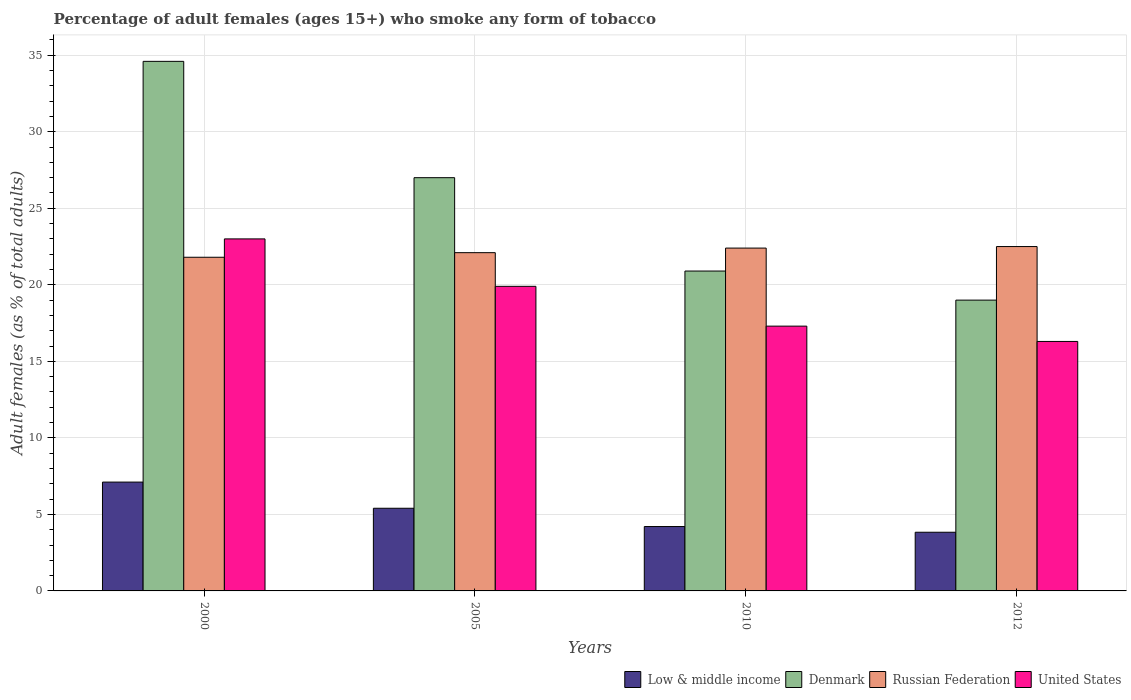How many different coloured bars are there?
Offer a very short reply. 4. How many groups of bars are there?
Keep it short and to the point. 4. Are the number of bars per tick equal to the number of legend labels?
Make the answer very short. Yes. In how many cases, is the number of bars for a given year not equal to the number of legend labels?
Make the answer very short. 0. What is the percentage of adult females who smoke in Denmark in 2010?
Make the answer very short. 20.9. In which year was the percentage of adult females who smoke in Low & middle income maximum?
Offer a terse response. 2000. What is the total percentage of adult females who smoke in United States in the graph?
Your answer should be very brief. 76.5. What is the difference between the percentage of adult females who smoke in United States in 2000 and that in 2005?
Provide a succinct answer. 3.1. What is the difference between the percentage of adult females who smoke in Denmark in 2010 and the percentage of adult females who smoke in United States in 2012?
Your answer should be compact. 4.6. What is the average percentage of adult females who smoke in United States per year?
Your answer should be compact. 19.12. In the year 2005, what is the difference between the percentage of adult females who smoke in Denmark and percentage of adult females who smoke in United States?
Give a very brief answer. 7.1. In how many years, is the percentage of adult females who smoke in Low & middle income greater than 7 %?
Provide a short and direct response. 1. What is the ratio of the percentage of adult females who smoke in Russian Federation in 2005 to that in 2010?
Your response must be concise. 0.99. Is the percentage of adult females who smoke in Denmark in 2000 less than that in 2010?
Offer a terse response. No. What is the difference between the highest and the second highest percentage of adult females who smoke in Denmark?
Ensure brevity in your answer.  7.6. What is the difference between the highest and the lowest percentage of adult females who smoke in Low & middle income?
Ensure brevity in your answer.  3.28. Is the sum of the percentage of adult females who smoke in Denmark in 2005 and 2012 greater than the maximum percentage of adult females who smoke in United States across all years?
Offer a terse response. Yes. What does the 1st bar from the left in 2000 represents?
Offer a terse response. Low & middle income. Are all the bars in the graph horizontal?
Your response must be concise. No. How many years are there in the graph?
Give a very brief answer. 4. What is the difference between two consecutive major ticks on the Y-axis?
Provide a short and direct response. 5. Does the graph contain grids?
Provide a short and direct response. Yes. Where does the legend appear in the graph?
Provide a succinct answer. Bottom right. How are the legend labels stacked?
Your answer should be very brief. Horizontal. What is the title of the graph?
Offer a very short reply. Percentage of adult females (ages 15+) who smoke any form of tobacco. What is the label or title of the Y-axis?
Your answer should be compact. Adult females (as % of total adults). What is the Adult females (as % of total adults) of Low & middle income in 2000?
Your answer should be compact. 7.11. What is the Adult females (as % of total adults) of Denmark in 2000?
Ensure brevity in your answer.  34.6. What is the Adult females (as % of total adults) of Russian Federation in 2000?
Give a very brief answer. 21.8. What is the Adult females (as % of total adults) in Low & middle income in 2005?
Offer a very short reply. 5.4. What is the Adult females (as % of total adults) in Russian Federation in 2005?
Offer a very short reply. 22.1. What is the Adult females (as % of total adults) of Low & middle income in 2010?
Your answer should be compact. 4.21. What is the Adult females (as % of total adults) of Denmark in 2010?
Make the answer very short. 20.9. What is the Adult females (as % of total adults) in Russian Federation in 2010?
Provide a succinct answer. 22.4. What is the Adult females (as % of total adults) in United States in 2010?
Offer a terse response. 17.3. What is the Adult females (as % of total adults) in Low & middle income in 2012?
Provide a short and direct response. 3.83. What is the Adult females (as % of total adults) of Russian Federation in 2012?
Offer a very short reply. 22.5. What is the Adult females (as % of total adults) of United States in 2012?
Your answer should be compact. 16.3. Across all years, what is the maximum Adult females (as % of total adults) of Low & middle income?
Your answer should be compact. 7.11. Across all years, what is the maximum Adult females (as % of total adults) of Denmark?
Provide a short and direct response. 34.6. Across all years, what is the maximum Adult females (as % of total adults) of Russian Federation?
Provide a short and direct response. 22.5. Across all years, what is the maximum Adult females (as % of total adults) of United States?
Provide a succinct answer. 23. Across all years, what is the minimum Adult females (as % of total adults) of Low & middle income?
Provide a short and direct response. 3.83. Across all years, what is the minimum Adult females (as % of total adults) in Russian Federation?
Ensure brevity in your answer.  21.8. Across all years, what is the minimum Adult females (as % of total adults) in United States?
Give a very brief answer. 16.3. What is the total Adult females (as % of total adults) of Low & middle income in the graph?
Keep it short and to the point. 20.55. What is the total Adult females (as % of total adults) in Denmark in the graph?
Provide a short and direct response. 101.5. What is the total Adult females (as % of total adults) in Russian Federation in the graph?
Ensure brevity in your answer.  88.8. What is the total Adult females (as % of total adults) in United States in the graph?
Offer a very short reply. 76.5. What is the difference between the Adult females (as % of total adults) in Low & middle income in 2000 and that in 2005?
Your response must be concise. 1.71. What is the difference between the Adult females (as % of total adults) in Denmark in 2000 and that in 2005?
Ensure brevity in your answer.  7.6. What is the difference between the Adult females (as % of total adults) of United States in 2000 and that in 2005?
Your answer should be compact. 3.1. What is the difference between the Adult females (as % of total adults) of Low & middle income in 2000 and that in 2010?
Your response must be concise. 2.9. What is the difference between the Adult females (as % of total adults) in United States in 2000 and that in 2010?
Ensure brevity in your answer.  5.7. What is the difference between the Adult females (as % of total adults) in Low & middle income in 2000 and that in 2012?
Ensure brevity in your answer.  3.28. What is the difference between the Adult females (as % of total adults) in Russian Federation in 2000 and that in 2012?
Make the answer very short. -0.7. What is the difference between the Adult females (as % of total adults) of United States in 2000 and that in 2012?
Your response must be concise. 6.7. What is the difference between the Adult females (as % of total adults) in Low & middle income in 2005 and that in 2010?
Provide a short and direct response. 1.19. What is the difference between the Adult females (as % of total adults) in Denmark in 2005 and that in 2010?
Your answer should be very brief. 6.1. What is the difference between the Adult females (as % of total adults) in Low & middle income in 2005 and that in 2012?
Make the answer very short. 1.57. What is the difference between the Adult females (as % of total adults) in Denmark in 2005 and that in 2012?
Your answer should be compact. 8. What is the difference between the Adult females (as % of total adults) of Russian Federation in 2005 and that in 2012?
Offer a terse response. -0.4. What is the difference between the Adult females (as % of total adults) in United States in 2005 and that in 2012?
Your answer should be very brief. 3.6. What is the difference between the Adult females (as % of total adults) in Low & middle income in 2010 and that in 2012?
Make the answer very short. 0.37. What is the difference between the Adult females (as % of total adults) of Low & middle income in 2000 and the Adult females (as % of total adults) of Denmark in 2005?
Offer a terse response. -19.89. What is the difference between the Adult females (as % of total adults) in Low & middle income in 2000 and the Adult females (as % of total adults) in Russian Federation in 2005?
Your answer should be very brief. -14.99. What is the difference between the Adult females (as % of total adults) in Low & middle income in 2000 and the Adult females (as % of total adults) in United States in 2005?
Offer a terse response. -12.79. What is the difference between the Adult females (as % of total adults) of Russian Federation in 2000 and the Adult females (as % of total adults) of United States in 2005?
Offer a terse response. 1.9. What is the difference between the Adult females (as % of total adults) in Low & middle income in 2000 and the Adult females (as % of total adults) in Denmark in 2010?
Ensure brevity in your answer.  -13.79. What is the difference between the Adult females (as % of total adults) in Low & middle income in 2000 and the Adult females (as % of total adults) in Russian Federation in 2010?
Your answer should be very brief. -15.29. What is the difference between the Adult females (as % of total adults) in Low & middle income in 2000 and the Adult females (as % of total adults) in United States in 2010?
Offer a very short reply. -10.19. What is the difference between the Adult females (as % of total adults) in Low & middle income in 2000 and the Adult females (as % of total adults) in Denmark in 2012?
Offer a terse response. -11.89. What is the difference between the Adult females (as % of total adults) of Low & middle income in 2000 and the Adult females (as % of total adults) of Russian Federation in 2012?
Give a very brief answer. -15.39. What is the difference between the Adult females (as % of total adults) in Low & middle income in 2000 and the Adult females (as % of total adults) in United States in 2012?
Provide a short and direct response. -9.19. What is the difference between the Adult females (as % of total adults) in Denmark in 2000 and the Adult females (as % of total adults) in Russian Federation in 2012?
Make the answer very short. 12.1. What is the difference between the Adult females (as % of total adults) of Low & middle income in 2005 and the Adult females (as % of total adults) of Denmark in 2010?
Provide a short and direct response. -15.5. What is the difference between the Adult females (as % of total adults) of Low & middle income in 2005 and the Adult females (as % of total adults) of Russian Federation in 2010?
Keep it short and to the point. -17. What is the difference between the Adult females (as % of total adults) in Low & middle income in 2005 and the Adult females (as % of total adults) in United States in 2010?
Provide a short and direct response. -11.9. What is the difference between the Adult females (as % of total adults) of Denmark in 2005 and the Adult females (as % of total adults) of United States in 2010?
Make the answer very short. 9.7. What is the difference between the Adult females (as % of total adults) in Russian Federation in 2005 and the Adult females (as % of total adults) in United States in 2010?
Provide a succinct answer. 4.8. What is the difference between the Adult females (as % of total adults) in Low & middle income in 2005 and the Adult females (as % of total adults) in Denmark in 2012?
Your response must be concise. -13.6. What is the difference between the Adult females (as % of total adults) of Low & middle income in 2005 and the Adult females (as % of total adults) of Russian Federation in 2012?
Your response must be concise. -17.1. What is the difference between the Adult females (as % of total adults) in Low & middle income in 2005 and the Adult females (as % of total adults) in United States in 2012?
Your answer should be very brief. -10.9. What is the difference between the Adult females (as % of total adults) in Denmark in 2005 and the Adult females (as % of total adults) in Russian Federation in 2012?
Keep it short and to the point. 4.5. What is the difference between the Adult females (as % of total adults) in Russian Federation in 2005 and the Adult females (as % of total adults) in United States in 2012?
Your answer should be very brief. 5.8. What is the difference between the Adult females (as % of total adults) in Low & middle income in 2010 and the Adult females (as % of total adults) in Denmark in 2012?
Offer a very short reply. -14.79. What is the difference between the Adult females (as % of total adults) of Low & middle income in 2010 and the Adult females (as % of total adults) of Russian Federation in 2012?
Keep it short and to the point. -18.29. What is the difference between the Adult females (as % of total adults) in Low & middle income in 2010 and the Adult females (as % of total adults) in United States in 2012?
Keep it short and to the point. -12.09. What is the difference between the Adult females (as % of total adults) in Denmark in 2010 and the Adult females (as % of total adults) in United States in 2012?
Your response must be concise. 4.6. What is the average Adult females (as % of total adults) of Low & middle income per year?
Keep it short and to the point. 5.14. What is the average Adult females (as % of total adults) in Denmark per year?
Keep it short and to the point. 25.38. What is the average Adult females (as % of total adults) of United States per year?
Your answer should be compact. 19.12. In the year 2000, what is the difference between the Adult females (as % of total adults) in Low & middle income and Adult females (as % of total adults) in Denmark?
Make the answer very short. -27.49. In the year 2000, what is the difference between the Adult females (as % of total adults) of Low & middle income and Adult females (as % of total adults) of Russian Federation?
Your answer should be very brief. -14.69. In the year 2000, what is the difference between the Adult females (as % of total adults) in Low & middle income and Adult females (as % of total adults) in United States?
Provide a short and direct response. -15.89. In the year 2000, what is the difference between the Adult females (as % of total adults) in Denmark and Adult females (as % of total adults) in Russian Federation?
Give a very brief answer. 12.8. In the year 2000, what is the difference between the Adult females (as % of total adults) in Denmark and Adult females (as % of total adults) in United States?
Your answer should be very brief. 11.6. In the year 2000, what is the difference between the Adult females (as % of total adults) in Russian Federation and Adult females (as % of total adults) in United States?
Keep it short and to the point. -1.2. In the year 2005, what is the difference between the Adult females (as % of total adults) in Low & middle income and Adult females (as % of total adults) in Denmark?
Offer a terse response. -21.6. In the year 2005, what is the difference between the Adult females (as % of total adults) in Low & middle income and Adult females (as % of total adults) in Russian Federation?
Give a very brief answer. -16.7. In the year 2005, what is the difference between the Adult females (as % of total adults) of Low & middle income and Adult females (as % of total adults) of United States?
Keep it short and to the point. -14.5. In the year 2005, what is the difference between the Adult females (as % of total adults) in Denmark and Adult females (as % of total adults) in Russian Federation?
Give a very brief answer. 4.9. In the year 2005, what is the difference between the Adult females (as % of total adults) of Russian Federation and Adult females (as % of total adults) of United States?
Offer a terse response. 2.2. In the year 2010, what is the difference between the Adult females (as % of total adults) in Low & middle income and Adult females (as % of total adults) in Denmark?
Your answer should be compact. -16.69. In the year 2010, what is the difference between the Adult females (as % of total adults) in Low & middle income and Adult females (as % of total adults) in Russian Federation?
Your answer should be very brief. -18.19. In the year 2010, what is the difference between the Adult females (as % of total adults) of Low & middle income and Adult females (as % of total adults) of United States?
Keep it short and to the point. -13.09. In the year 2010, what is the difference between the Adult females (as % of total adults) of Denmark and Adult females (as % of total adults) of Russian Federation?
Provide a short and direct response. -1.5. In the year 2010, what is the difference between the Adult females (as % of total adults) of Russian Federation and Adult females (as % of total adults) of United States?
Provide a succinct answer. 5.1. In the year 2012, what is the difference between the Adult females (as % of total adults) in Low & middle income and Adult females (as % of total adults) in Denmark?
Your response must be concise. -15.17. In the year 2012, what is the difference between the Adult females (as % of total adults) of Low & middle income and Adult females (as % of total adults) of Russian Federation?
Make the answer very short. -18.67. In the year 2012, what is the difference between the Adult females (as % of total adults) of Low & middle income and Adult females (as % of total adults) of United States?
Offer a terse response. -12.47. In the year 2012, what is the difference between the Adult females (as % of total adults) of Denmark and Adult females (as % of total adults) of United States?
Give a very brief answer. 2.7. In the year 2012, what is the difference between the Adult females (as % of total adults) of Russian Federation and Adult females (as % of total adults) of United States?
Provide a succinct answer. 6.2. What is the ratio of the Adult females (as % of total adults) in Low & middle income in 2000 to that in 2005?
Your answer should be very brief. 1.32. What is the ratio of the Adult females (as % of total adults) of Denmark in 2000 to that in 2005?
Keep it short and to the point. 1.28. What is the ratio of the Adult females (as % of total adults) of Russian Federation in 2000 to that in 2005?
Your response must be concise. 0.99. What is the ratio of the Adult females (as % of total adults) in United States in 2000 to that in 2005?
Give a very brief answer. 1.16. What is the ratio of the Adult females (as % of total adults) in Low & middle income in 2000 to that in 2010?
Keep it short and to the point. 1.69. What is the ratio of the Adult females (as % of total adults) in Denmark in 2000 to that in 2010?
Ensure brevity in your answer.  1.66. What is the ratio of the Adult females (as % of total adults) in Russian Federation in 2000 to that in 2010?
Your answer should be very brief. 0.97. What is the ratio of the Adult females (as % of total adults) in United States in 2000 to that in 2010?
Give a very brief answer. 1.33. What is the ratio of the Adult females (as % of total adults) in Low & middle income in 2000 to that in 2012?
Give a very brief answer. 1.85. What is the ratio of the Adult females (as % of total adults) of Denmark in 2000 to that in 2012?
Make the answer very short. 1.82. What is the ratio of the Adult females (as % of total adults) in Russian Federation in 2000 to that in 2012?
Provide a short and direct response. 0.97. What is the ratio of the Adult females (as % of total adults) in United States in 2000 to that in 2012?
Offer a very short reply. 1.41. What is the ratio of the Adult females (as % of total adults) in Low & middle income in 2005 to that in 2010?
Your answer should be compact. 1.28. What is the ratio of the Adult females (as % of total adults) in Denmark in 2005 to that in 2010?
Give a very brief answer. 1.29. What is the ratio of the Adult females (as % of total adults) in Russian Federation in 2005 to that in 2010?
Offer a terse response. 0.99. What is the ratio of the Adult females (as % of total adults) in United States in 2005 to that in 2010?
Provide a succinct answer. 1.15. What is the ratio of the Adult females (as % of total adults) in Low & middle income in 2005 to that in 2012?
Provide a succinct answer. 1.41. What is the ratio of the Adult females (as % of total adults) of Denmark in 2005 to that in 2012?
Make the answer very short. 1.42. What is the ratio of the Adult females (as % of total adults) in Russian Federation in 2005 to that in 2012?
Ensure brevity in your answer.  0.98. What is the ratio of the Adult females (as % of total adults) in United States in 2005 to that in 2012?
Provide a short and direct response. 1.22. What is the ratio of the Adult females (as % of total adults) in Low & middle income in 2010 to that in 2012?
Provide a short and direct response. 1.1. What is the ratio of the Adult females (as % of total adults) of Russian Federation in 2010 to that in 2012?
Offer a terse response. 1. What is the ratio of the Adult females (as % of total adults) in United States in 2010 to that in 2012?
Provide a succinct answer. 1.06. What is the difference between the highest and the second highest Adult females (as % of total adults) in Low & middle income?
Make the answer very short. 1.71. What is the difference between the highest and the second highest Adult females (as % of total adults) in United States?
Offer a terse response. 3.1. What is the difference between the highest and the lowest Adult females (as % of total adults) of Low & middle income?
Keep it short and to the point. 3.28. What is the difference between the highest and the lowest Adult females (as % of total adults) of Denmark?
Your response must be concise. 15.6. 